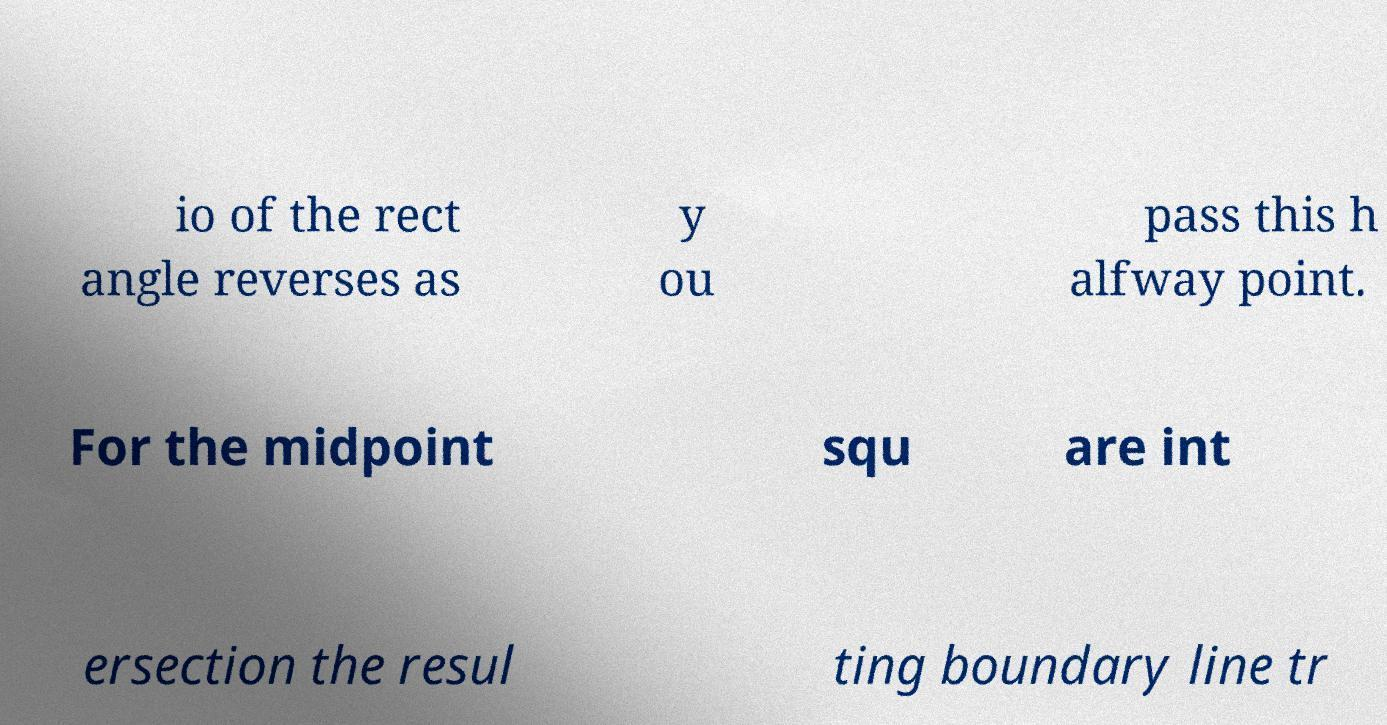Can you accurately transcribe the text from the provided image for me? io of the rect angle reverses as y ou pass this h alfway point. For the midpoint squ are int ersection the resul ting boundary line tr 